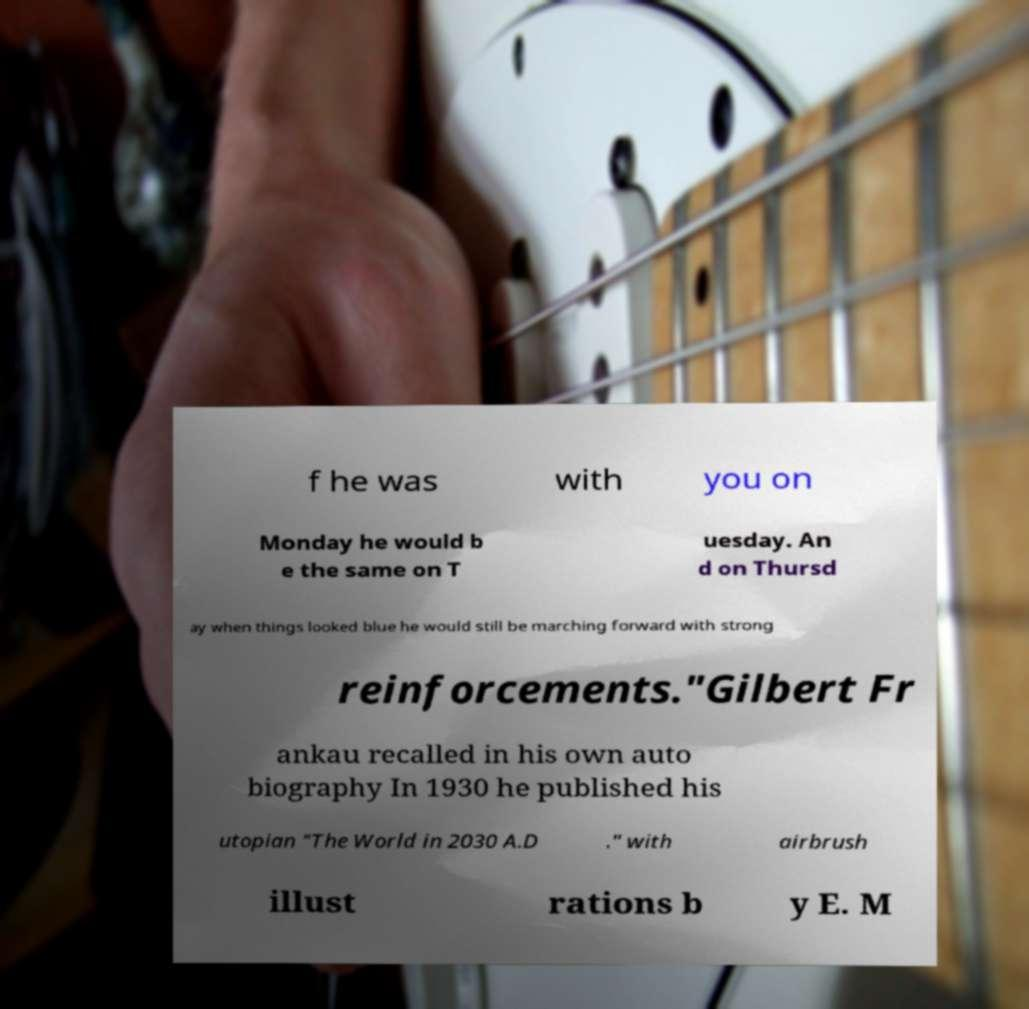Could you extract and type out the text from this image? f he was with you on Monday he would b e the same on T uesday. An d on Thursd ay when things looked blue he would still be marching forward with strong reinforcements."Gilbert Fr ankau recalled in his own auto biography In 1930 he published his utopian "The World in 2030 A.D ." with airbrush illust rations b y E. M 